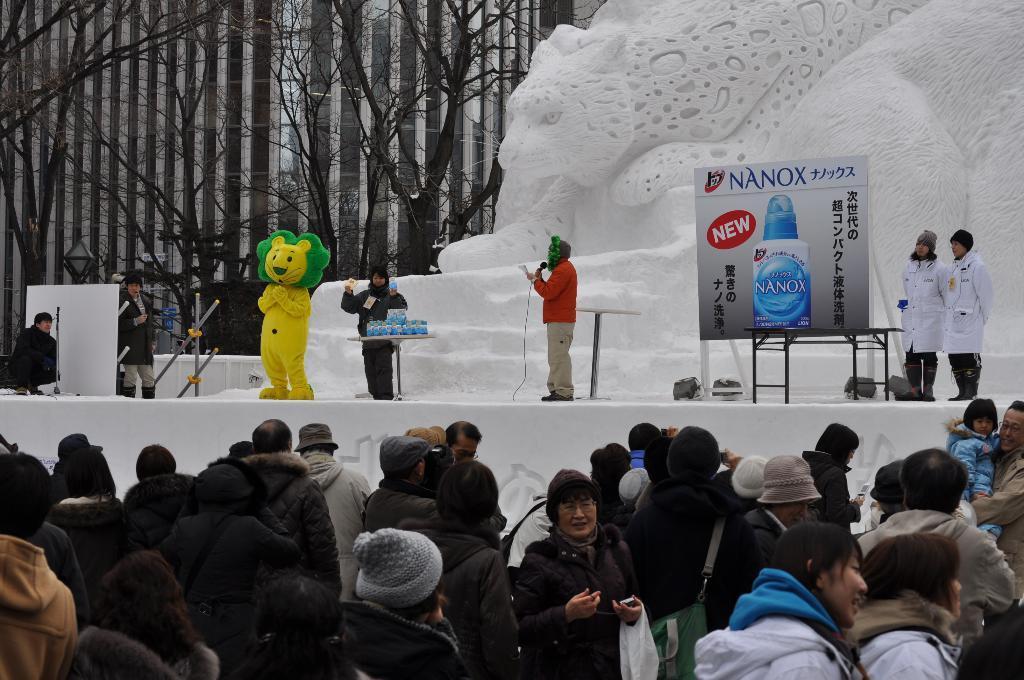Could you give a brief overview of what you see in this image? In this image I can see few people standing and wearing bags and something. I can see few people standing on stage and one person is holding mic. I can see a board and few objects. I can see a yellow and green color costume dress,trees and a snow craving at back. 